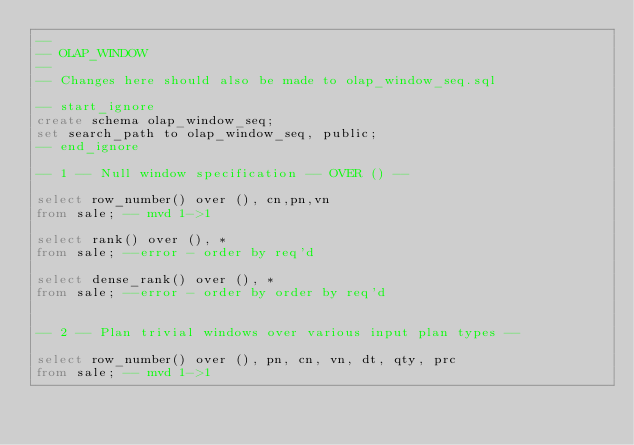<code> <loc_0><loc_0><loc_500><loc_500><_SQL_>--
-- OLAP_WINDOW 
--
-- Changes here should also be made to olap_window_seq.sql

-- start_ignore
create schema olap_window_seq;
set search_path to olap_window_seq, public;
-- end_ignore

-- 1 -- Null window specification -- OVER () --

select row_number() over (), cn,pn,vn 
from sale; -- mvd 1->1

select rank() over (), * 
from sale; --error - order by req'd

select dense_rank() over (), * 
from sale; --error - order by order by req'd


-- 2 -- Plan trivial windows over various input plan types --

select row_number() over (), pn, cn, vn, dt, qty, prc
from sale; -- mvd 1->1
</code> 